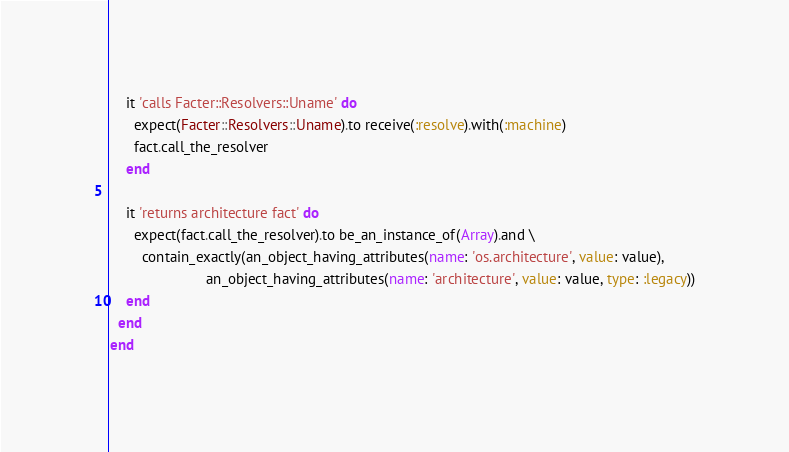Convert code to text. <code><loc_0><loc_0><loc_500><loc_500><_Ruby_>    it 'calls Facter::Resolvers::Uname' do
      expect(Facter::Resolvers::Uname).to receive(:resolve).with(:machine)
      fact.call_the_resolver
    end

    it 'returns architecture fact' do
      expect(fact.call_the_resolver).to be_an_instance_of(Array).and \
        contain_exactly(an_object_having_attributes(name: 'os.architecture', value: value),
                        an_object_having_attributes(name: 'architecture', value: value, type: :legacy))
    end
  end
end
</code> 